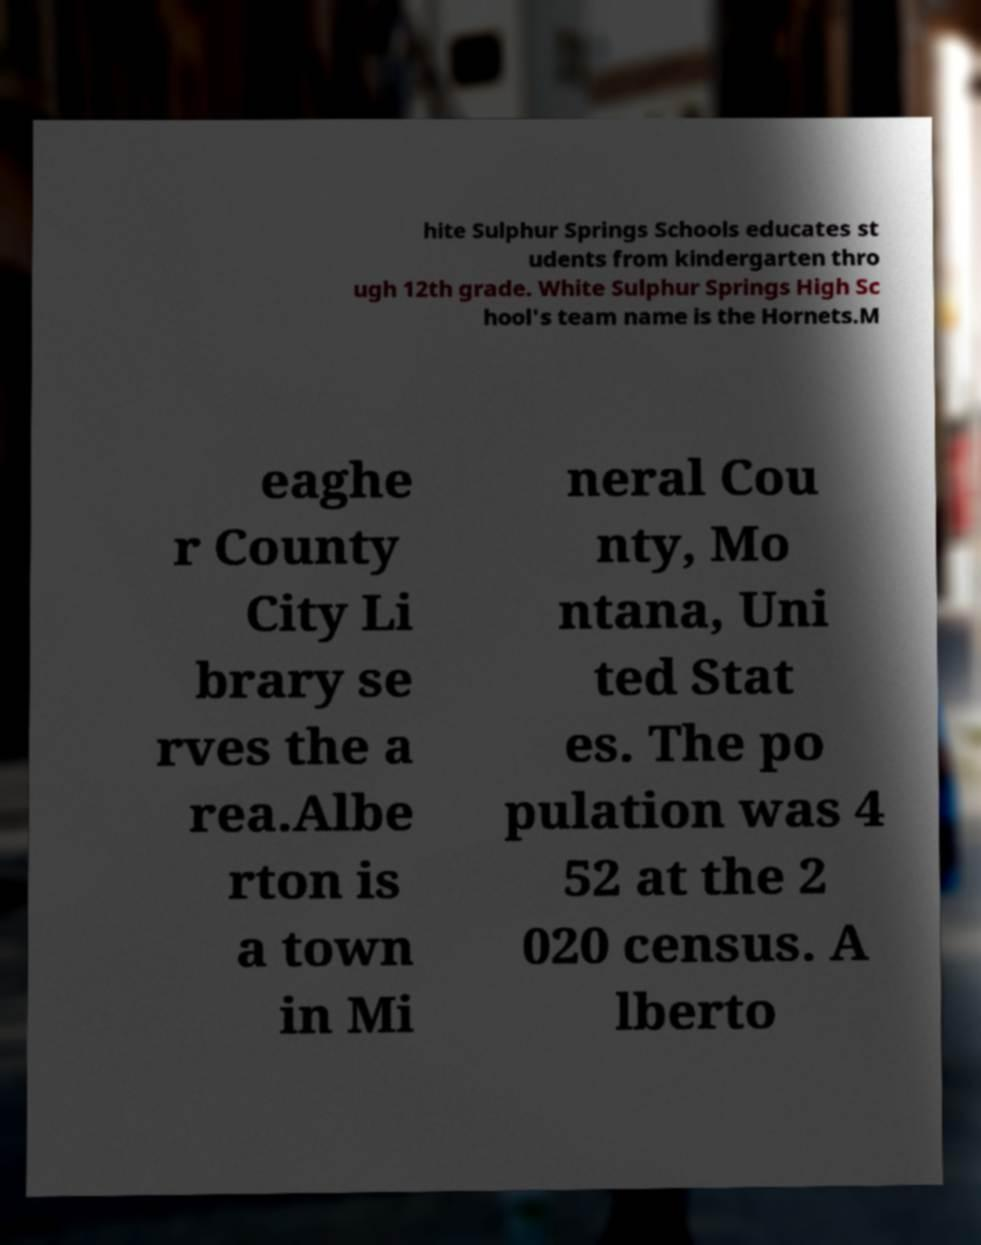Please identify and transcribe the text found in this image. hite Sulphur Springs Schools educates st udents from kindergarten thro ugh 12th grade. White Sulphur Springs High Sc hool's team name is the Hornets.M eaghe r County City Li brary se rves the a rea.Albe rton is a town in Mi neral Cou nty, Mo ntana, Uni ted Stat es. The po pulation was 4 52 at the 2 020 census. A lberto 